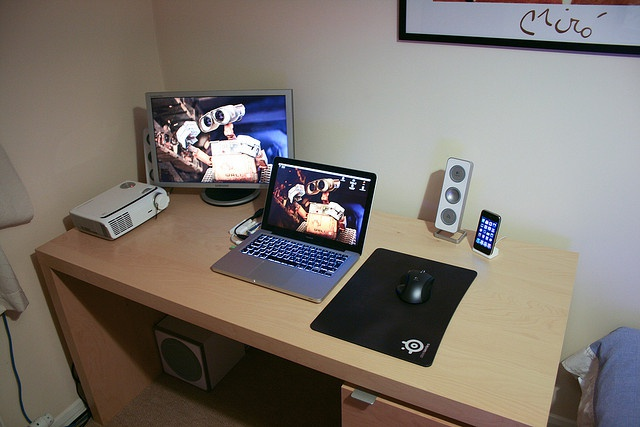Describe the objects in this image and their specific colors. I can see laptop in black, gray, and white tones, tv in black, white, gray, and navy tones, mouse in black, gray, darkgray, and purple tones, and cell phone in black, darkblue, navy, and white tones in this image. 